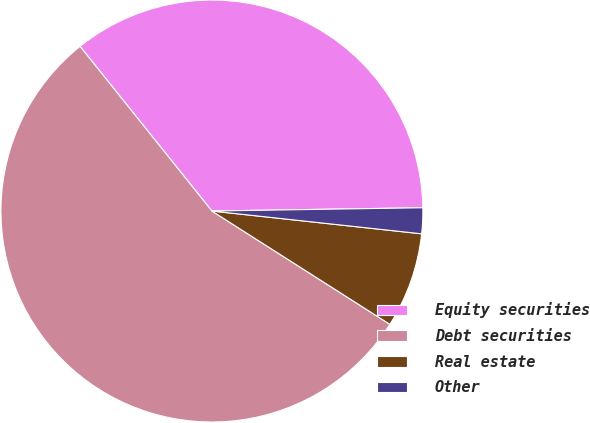Convert chart. <chart><loc_0><loc_0><loc_500><loc_500><pie_chart><fcel>Equity securities<fcel>Debt securities<fcel>Real estate<fcel>Other<nl><fcel>35.5%<fcel>55.23%<fcel>7.3%<fcel>1.97%<nl></chart> 